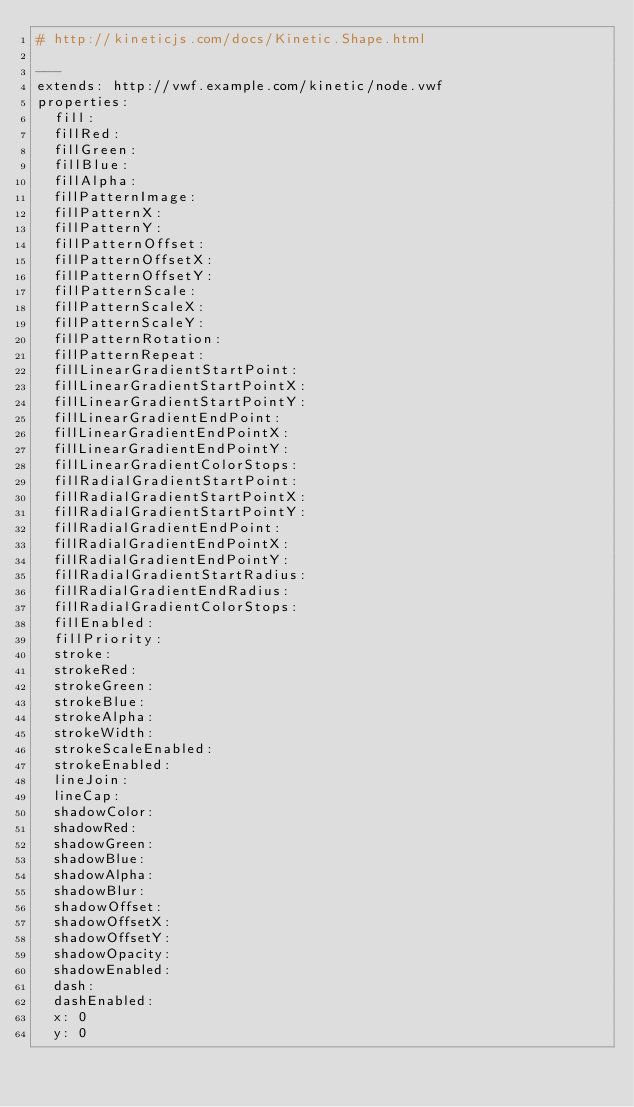<code> <loc_0><loc_0><loc_500><loc_500><_YAML_># http://kineticjs.com/docs/Kinetic.Shape.html

--- 
extends: http://vwf.example.com/kinetic/node.vwf
properties:
  fill:
  fillRed:
  fillGreen:
  fillBlue:
  fillAlpha:
  fillPatternImage:
  fillPatternX:
  fillPatternY:
  fillPatternOffset:
  fillPatternOffsetX:
  fillPatternOffsetY:
  fillPatternScale:
  fillPatternScaleX:
  fillPatternScaleY:
  fillPatternRotation:
  fillPatternRepeat:
  fillLinearGradientStartPoint:
  fillLinearGradientStartPointX:
  fillLinearGradientStartPointY:
  fillLinearGradientEndPoint:
  fillLinearGradientEndPointX:
  fillLinearGradientEndPointY:
  fillLinearGradientColorStops:
  fillRadialGradientStartPoint:
  fillRadialGradientStartPointX:
  fillRadialGradientStartPointY:
  fillRadialGradientEndPoint:
  fillRadialGradientEndPointX:
  fillRadialGradientEndPointY:
  fillRadialGradientStartRadius:
  fillRadialGradientEndRadius:
  fillRadialGradientColorStops:
  fillEnabled:
  fillPriority:
  stroke:
  strokeRed:
  strokeGreen:
  strokeBlue:
  strokeAlpha:
  strokeWidth:
  strokeScaleEnabled:
  strokeEnabled:
  lineJoin:
  lineCap:
  shadowColor:
  shadowRed:
  shadowGreen:
  shadowBlue:
  shadowAlpha:
  shadowBlur:
  shadowOffset:
  shadowOffsetX:
  shadowOffsetY:
  shadowOpacity:
  shadowEnabled:
  dash:
  dashEnabled:
  x: 0
  y: 0</code> 